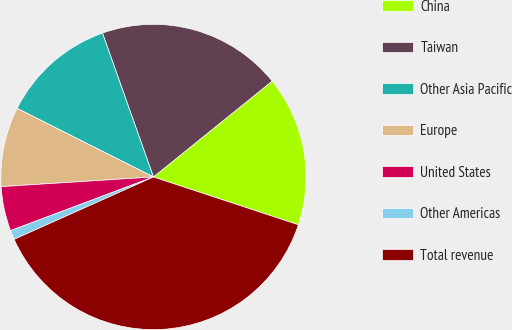<chart> <loc_0><loc_0><loc_500><loc_500><pie_chart><fcel>China<fcel>Taiwan<fcel>Other Asia Pacific<fcel>Europe<fcel>United States<fcel>Other Americas<fcel>Total revenue<nl><fcel>15.88%<fcel>19.61%<fcel>12.16%<fcel>8.43%<fcel>4.71%<fcel>0.98%<fcel>38.23%<nl></chart> 